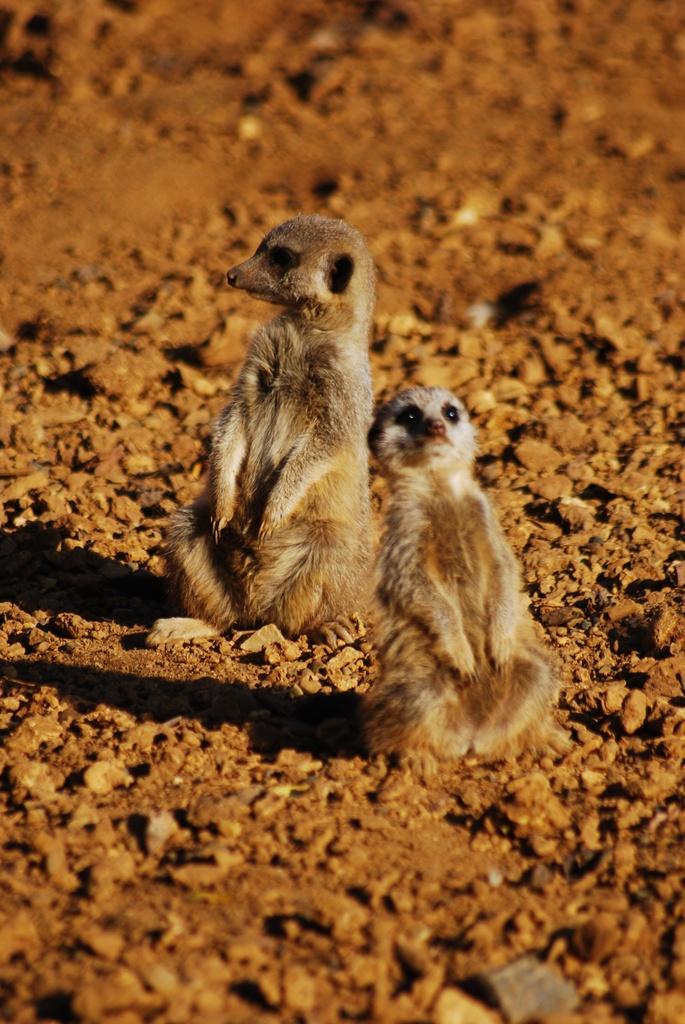Could you give a brief overview of what you see in this image? In this image I can see two meerkats and shadows over here. 